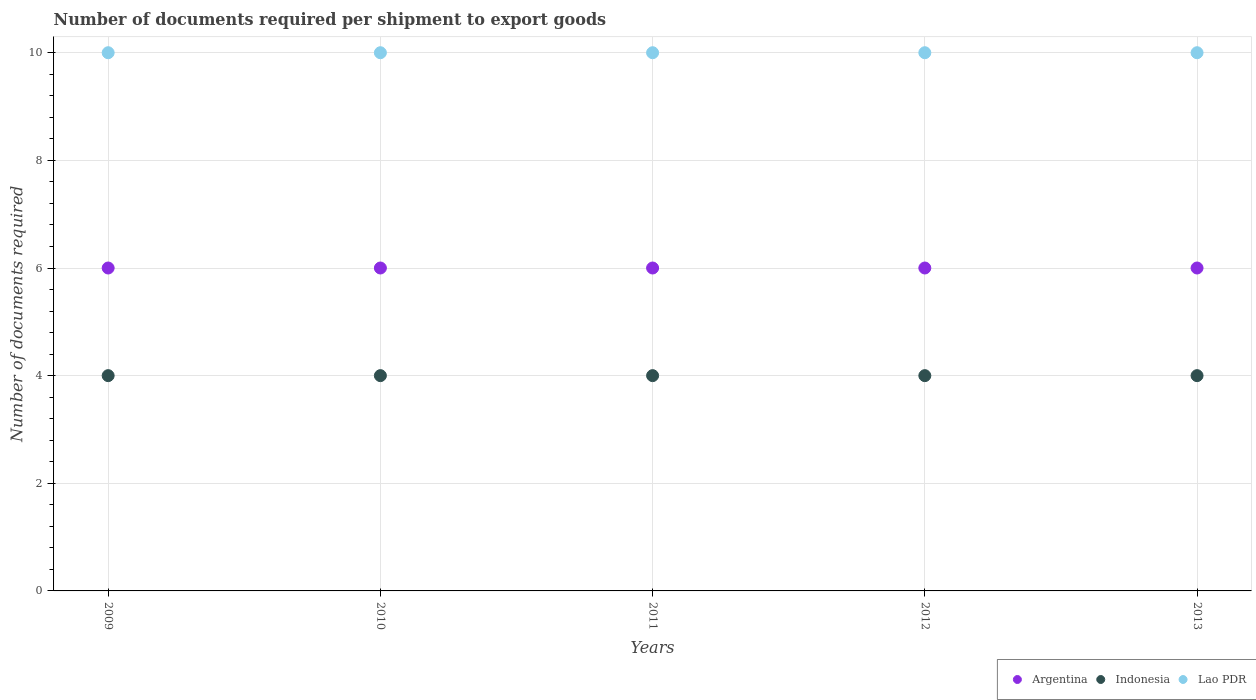How many different coloured dotlines are there?
Your answer should be very brief. 3. Is the number of dotlines equal to the number of legend labels?
Offer a terse response. Yes. What is the number of documents required per shipment to export goods in Indonesia in 2013?
Make the answer very short. 4. Across all years, what is the maximum number of documents required per shipment to export goods in Indonesia?
Your answer should be very brief. 4. Across all years, what is the minimum number of documents required per shipment to export goods in Indonesia?
Your answer should be compact. 4. What is the total number of documents required per shipment to export goods in Argentina in the graph?
Give a very brief answer. 30. What is the difference between the number of documents required per shipment to export goods in Argentina in 2011 and the number of documents required per shipment to export goods in Lao PDR in 2013?
Your response must be concise. -4. What is the average number of documents required per shipment to export goods in Lao PDR per year?
Your response must be concise. 10. In the year 2009, what is the difference between the number of documents required per shipment to export goods in Lao PDR and number of documents required per shipment to export goods in Argentina?
Keep it short and to the point. 4. In how many years, is the number of documents required per shipment to export goods in Indonesia greater than 4.8?
Provide a succinct answer. 0. What is the difference between the highest and the second highest number of documents required per shipment to export goods in Indonesia?
Ensure brevity in your answer.  0. In how many years, is the number of documents required per shipment to export goods in Indonesia greater than the average number of documents required per shipment to export goods in Indonesia taken over all years?
Your answer should be compact. 0. Is the sum of the number of documents required per shipment to export goods in Argentina in 2009 and 2012 greater than the maximum number of documents required per shipment to export goods in Lao PDR across all years?
Give a very brief answer. Yes. Does the number of documents required per shipment to export goods in Indonesia monotonically increase over the years?
Make the answer very short. No. Is the number of documents required per shipment to export goods in Argentina strictly greater than the number of documents required per shipment to export goods in Indonesia over the years?
Offer a very short reply. Yes. Is the number of documents required per shipment to export goods in Indonesia strictly less than the number of documents required per shipment to export goods in Argentina over the years?
Provide a short and direct response. Yes. What is the difference between two consecutive major ticks on the Y-axis?
Make the answer very short. 2. Does the graph contain any zero values?
Your answer should be compact. No. Where does the legend appear in the graph?
Your answer should be very brief. Bottom right. How are the legend labels stacked?
Provide a succinct answer. Horizontal. What is the title of the graph?
Keep it short and to the point. Number of documents required per shipment to export goods. Does "Pakistan" appear as one of the legend labels in the graph?
Offer a terse response. No. What is the label or title of the Y-axis?
Give a very brief answer. Number of documents required. What is the Number of documents required in Argentina in 2009?
Ensure brevity in your answer.  6. What is the Number of documents required in Indonesia in 2010?
Make the answer very short. 4. What is the Number of documents required in Argentina in 2011?
Provide a succinct answer. 6. What is the Number of documents required in Indonesia in 2011?
Offer a very short reply. 4. What is the Number of documents required in Indonesia in 2012?
Offer a terse response. 4. Across all years, what is the maximum Number of documents required in Indonesia?
Give a very brief answer. 4. Across all years, what is the minimum Number of documents required in Indonesia?
Keep it short and to the point. 4. What is the total Number of documents required of Lao PDR in the graph?
Your answer should be very brief. 50. What is the difference between the Number of documents required of Indonesia in 2009 and that in 2010?
Give a very brief answer. 0. What is the difference between the Number of documents required in Indonesia in 2009 and that in 2011?
Keep it short and to the point. 0. What is the difference between the Number of documents required in Lao PDR in 2009 and that in 2011?
Ensure brevity in your answer.  0. What is the difference between the Number of documents required in Argentina in 2009 and that in 2012?
Provide a short and direct response. 0. What is the difference between the Number of documents required in Indonesia in 2009 and that in 2012?
Provide a short and direct response. 0. What is the difference between the Number of documents required in Lao PDR in 2009 and that in 2012?
Your answer should be very brief. 0. What is the difference between the Number of documents required in Argentina in 2010 and that in 2011?
Offer a very short reply. 0. What is the difference between the Number of documents required in Indonesia in 2010 and that in 2011?
Offer a terse response. 0. What is the difference between the Number of documents required of Argentina in 2010 and that in 2013?
Offer a terse response. 0. What is the difference between the Number of documents required of Indonesia in 2010 and that in 2013?
Your response must be concise. 0. What is the difference between the Number of documents required in Argentina in 2011 and that in 2012?
Make the answer very short. 0. What is the difference between the Number of documents required of Lao PDR in 2011 and that in 2012?
Ensure brevity in your answer.  0. What is the difference between the Number of documents required of Indonesia in 2011 and that in 2013?
Keep it short and to the point. 0. What is the difference between the Number of documents required of Lao PDR in 2011 and that in 2013?
Your response must be concise. 0. What is the difference between the Number of documents required in Argentina in 2009 and the Number of documents required in Indonesia in 2010?
Your answer should be very brief. 2. What is the difference between the Number of documents required in Argentina in 2009 and the Number of documents required in Lao PDR in 2010?
Your answer should be compact. -4. What is the difference between the Number of documents required in Indonesia in 2009 and the Number of documents required in Lao PDR in 2010?
Provide a short and direct response. -6. What is the difference between the Number of documents required of Argentina in 2009 and the Number of documents required of Indonesia in 2012?
Provide a short and direct response. 2. What is the difference between the Number of documents required in Argentina in 2009 and the Number of documents required in Lao PDR in 2012?
Give a very brief answer. -4. What is the difference between the Number of documents required in Argentina in 2009 and the Number of documents required in Indonesia in 2013?
Ensure brevity in your answer.  2. What is the difference between the Number of documents required of Indonesia in 2009 and the Number of documents required of Lao PDR in 2013?
Your answer should be compact. -6. What is the difference between the Number of documents required of Argentina in 2010 and the Number of documents required of Indonesia in 2011?
Offer a terse response. 2. What is the difference between the Number of documents required of Argentina in 2010 and the Number of documents required of Indonesia in 2013?
Keep it short and to the point. 2. What is the difference between the Number of documents required of Indonesia in 2010 and the Number of documents required of Lao PDR in 2013?
Your answer should be compact. -6. What is the difference between the Number of documents required of Argentina in 2011 and the Number of documents required of Indonesia in 2012?
Offer a terse response. 2. What is the difference between the Number of documents required of Argentina in 2011 and the Number of documents required of Indonesia in 2013?
Provide a succinct answer. 2. What is the difference between the Number of documents required in Indonesia in 2011 and the Number of documents required in Lao PDR in 2013?
Offer a terse response. -6. What is the difference between the Number of documents required in Argentina in 2012 and the Number of documents required in Indonesia in 2013?
Your answer should be compact. 2. What is the difference between the Number of documents required in Indonesia in 2012 and the Number of documents required in Lao PDR in 2013?
Ensure brevity in your answer.  -6. What is the average Number of documents required in Argentina per year?
Keep it short and to the point. 6. What is the average Number of documents required of Indonesia per year?
Your response must be concise. 4. What is the average Number of documents required in Lao PDR per year?
Your answer should be very brief. 10. In the year 2009, what is the difference between the Number of documents required in Argentina and Number of documents required in Indonesia?
Provide a succinct answer. 2. In the year 2009, what is the difference between the Number of documents required of Indonesia and Number of documents required of Lao PDR?
Your answer should be very brief. -6. In the year 2010, what is the difference between the Number of documents required of Argentina and Number of documents required of Lao PDR?
Provide a short and direct response. -4. In the year 2010, what is the difference between the Number of documents required in Indonesia and Number of documents required in Lao PDR?
Keep it short and to the point. -6. In the year 2012, what is the difference between the Number of documents required in Argentina and Number of documents required in Lao PDR?
Your answer should be very brief. -4. In the year 2013, what is the difference between the Number of documents required in Argentina and Number of documents required in Indonesia?
Offer a very short reply. 2. In the year 2013, what is the difference between the Number of documents required in Argentina and Number of documents required in Lao PDR?
Give a very brief answer. -4. In the year 2013, what is the difference between the Number of documents required of Indonesia and Number of documents required of Lao PDR?
Offer a very short reply. -6. What is the ratio of the Number of documents required of Argentina in 2009 to that in 2010?
Your answer should be very brief. 1. What is the ratio of the Number of documents required in Indonesia in 2009 to that in 2010?
Keep it short and to the point. 1. What is the ratio of the Number of documents required of Indonesia in 2009 to that in 2011?
Give a very brief answer. 1. What is the ratio of the Number of documents required of Lao PDR in 2009 to that in 2011?
Your response must be concise. 1. What is the ratio of the Number of documents required in Lao PDR in 2009 to that in 2012?
Provide a succinct answer. 1. What is the ratio of the Number of documents required in Lao PDR in 2009 to that in 2013?
Provide a short and direct response. 1. What is the ratio of the Number of documents required of Argentina in 2010 to that in 2011?
Keep it short and to the point. 1. What is the ratio of the Number of documents required of Indonesia in 2010 to that in 2011?
Ensure brevity in your answer.  1. What is the ratio of the Number of documents required of Lao PDR in 2010 to that in 2011?
Your answer should be very brief. 1. What is the ratio of the Number of documents required of Indonesia in 2010 to that in 2012?
Keep it short and to the point. 1. What is the ratio of the Number of documents required in Argentina in 2010 to that in 2013?
Provide a short and direct response. 1. What is the ratio of the Number of documents required in Indonesia in 2011 to that in 2012?
Your answer should be compact. 1. What is the ratio of the Number of documents required of Argentina in 2011 to that in 2013?
Make the answer very short. 1. What is the ratio of the Number of documents required of Indonesia in 2011 to that in 2013?
Give a very brief answer. 1. What is the difference between the highest and the second highest Number of documents required in Argentina?
Your answer should be very brief. 0. What is the difference between the highest and the second highest Number of documents required of Lao PDR?
Provide a succinct answer. 0. 